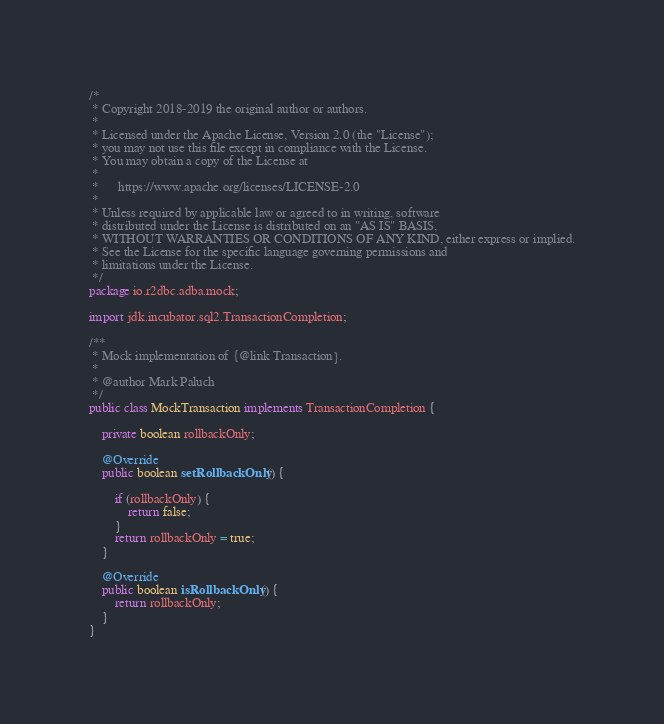<code> <loc_0><loc_0><loc_500><loc_500><_Java_>/*
 * Copyright 2018-2019 the original author or authors.
 *
 * Licensed under the Apache License, Version 2.0 (the "License");
 * you may not use this file except in compliance with the License.
 * You may obtain a copy of the License at
 *
 *      https://www.apache.org/licenses/LICENSE-2.0
 *
 * Unless required by applicable law or agreed to in writing, software
 * distributed under the License is distributed on an "AS IS" BASIS,
 * WITHOUT WARRANTIES OR CONDITIONS OF ANY KIND, either express or implied.
 * See the License for the specific language governing permissions and
 * limitations under the License.
 */
package io.r2dbc.adba.mock;

import jdk.incubator.sql2.TransactionCompletion;

/**
 * Mock implementation of {@link Transaction}.
 *
 * @author Mark Paluch
 */
public class MockTransaction implements TransactionCompletion {

    private boolean rollbackOnly;

    @Override
    public boolean setRollbackOnly() {

        if (rollbackOnly) {
            return false;
        }
        return rollbackOnly = true;
    }

    @Override
    public boolean isRollbackOnly() {
        return rollbackOnly;
    }
}
</code> 